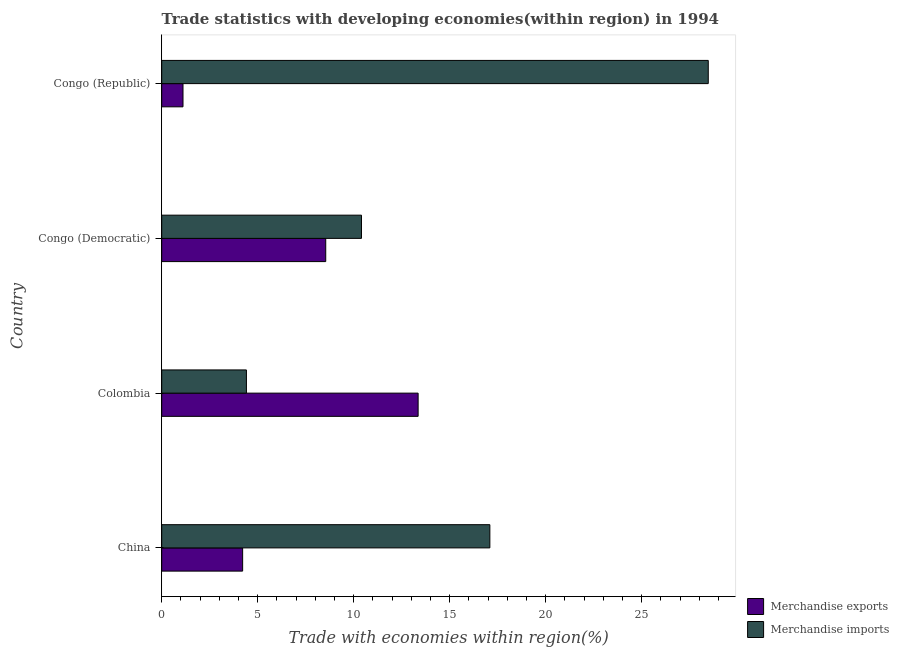How many bars are there on the 3rd tick from the top?
Make the answer very short. 2. What is the label of the 2nd group of bars from the top?
Offer a terse response. Congo (Democratic). In how many cases, is the number of bars for a given country not equal to the number of legend labels?
Make the answer very short. 0. What is the merchandise imports in China?
Make the answer very short. 17.09. Across all countries, what is the maximum merchandise imports?
Give a very brief answer. 28.47. Across all countries, what is the minimum merchandise imports?
Give a very brief answer. 4.41. In which country was the merchandise imports maximum?
Offer a very short reply. Congo (Republic). What is the total merchandise exports in the graph?
Provide a short and direct response. 27.22. What is the difference between the merchandise imports in China and that in Colombia?
Provide a succinct answer. 12.68. What is the difference between the merchandise imports in China and the merchandise exports in Congo (Republic)?
Your response must be concise. 15.98. What is the average merchandise exports per country?
Offer a terse response. 6.81. What is the difference between the merchandise imports and merchandise exports in Congo (Democratic)?
Provide a succinct answer. 1.86. In how many countries, is the merchandise exports greater than 9 %?
Provide a succinct answer. 1. What is the ratio of the merchandise exports in Colombia to that in Congo (Democratic)?
Give a very brief answer. 1.56. Is the difference between the merchandise imports in Colombia and Congo (Republic) greater than the difference between the merchandise exports in Colombia and Congo (Republic)?
Ensure brevity in your answer.  No. What is the difference between the highest and the second highest merchandise exports?
Provide a short and direct response. 4.81. What is the difference between the highest and the lowest merchandise imports?
Provide a succinct answer. 24.06. In how many countries, is the merchandise exports greater than the average merchandise exports taken over all countries?
Give a very brief answer. 2. What does the 1st bar from the top in China represents?
Give a very brief answer. Merchandise imports. Are all the bars in the graph horizontal?
Provide a succinct answer. Yes. How many countries are there in the graph?
Your response must be concise. 4. What is the difference between two consecutive major ticks on the X-axis?
Provide a succinct answer. 5. Does the graph contain any zero values?
Keep it short and to the point. No. Does the graph contain grids?
Provide a short and direct response. No. Where does the legend appear in the graph?
Ensure brevity in your answer.  Bottom right. How many legend labels are there?
Your answer should be compact. 2. What is the title of the graph?
Your response must be concise. Trade statistics with developing economies(within region) in 1994. Does "Investment" appear as one of the legend labels in the graph?
Give a very brief answer. No. What is the label or title of the X-axis?
Keep it short and to the point. Trade with economies within region(%). What is the label or title of the Y-axis?
Give a very brief answer. Country. What is the Trade with economies within region(%) in Merchandise exports in China?
Ensure brevity in your answer.  4.22. What is the Trade with economies within region(%) of Merchandise imports in China?
Your answer should be compact. 17.09. What is the Trade with economies within region(%) in Merchandise exports in Colombia?
Offer a terse response. 13.36. What is the Trade with economies within region(%) of Merchandise imports in Colombia?
Provide a short and direct response. 4.41. What is the Trade with economies within region(%) in Merchandise exports in Congo (Democratic)?
Your answer should be compact. 8.54. What is the Trade with economies within region(%) in Merchandise imports in Congo (Democratic)?
Offer a very short reply. 10.41. What is the Trade with economies within region(%) in Merchandise exports in Congo (Republic)?
Provide a succinct answer. 1.11. What is the Trade with economies within region(%) in Merchandise imports in Congo (Republic)?
Make the answer very short. 28.47. Across all countries, what is the maximum Trade with economies within region(%) in Merchandise exports?
Your answer should be compact. 13.36. Across all countries, what is the maximum Trade with economies within region(%) in Merchandise imports?
Offer a terse response. 28.47. Across all countries, what is the minimum Trade with economies within region(%) in Merchandise exports?
Give a very brief answer. 1.11. Across all countries, what is the minimum Trade with economies within region(%) of Merchandise imports?
Offer a terse response. 4.41. What is the total Trade with economies within region(%) of Merchandise exports in the graph?
Your answer should be very brief. 27.22. What is the total Trade with economies within region(%) of Merchandise imports in the graph?
Your answer should be very brief. 60.38. What is the difference between the Trade with economies within region(%) of Merchandise exports in China and that in Colombia?
Provide a short and direct response. -9.14. What is the difference between the Trade with economies within region(%) in Merchandise imports in China and that in Colombia?
Your response must be concise. 12.68. What is the difference between the Trade with economies within region(%) of Merchandise exports in China and that in Congo (Democratic)?
Make the answer very short. -4.33. What is the difference between the Trade with economies within region(%) in Merchandise imports in China and that in Congo (Democratic)?
Provide a short and direct response. 6.69. What is the difference between the Trade with economies within region(%) in Merchandise exports in China and that in Congo (Republic)?
Provide a short and direct response. 3.11. What is the difference between the Trade with economies within region(%) of Merchandise imports in China and that in Congo (Republic)?
Your response must be concise. -11.38. What is the difference between the Trade with economies within region(%) of Merchandise exports in Colombia and that in Congo (Democratic)?
Provide a succinct answer. 4.81. What is the difference between the Trade with economies within region(%) of Merchandise imports in Colombia and that in Congo (Democratic)?
Your response must be concise. -5.99. What is the difference between the Trade with economies within region(%) of Merchandise exports in Colombia and that in Congo (Republic)?
Make the answer very short. 12.25. What is the difference between the Trade with economies within region(%) in Merchandise imports in Colombia and that in Congo (Republic)?
Keep it short and to the point. -24.06. What is the difference between the Trade with economies within region(%) of Merchandise exports in Congo (Democratic) and that in Congo (Republic)?
Give a very brief answer. 7.43. What is the difference between the Trade with economies within region(%) in Merchandise imports in Congo (Democratic) and that in Congo (Republic)?
Offer a very short reply. -18.06. What is the difference between the Trade with economies within region(%) in Merchandise exports in China and the Trade with economies within region(%) in Merchandise imports in Colombia?
Your answer should be very brief. -0.2. What is the difference between the Trade with economies within region(%) in Merchandise exports in China and the Trade with economies within region(%) in Merchandise imports in Congo (Democratic)?
Offer a very short reply. -6.19. What is the difference between the Trade with economies within region(%) of Merchandise exports in China and the Trade with economies within region(%) of Merchandise imports in Congo (Republic)?
Give a very brief answer. -24.25. What is the difference between the Trade with economies within region(%) in Merchandise exports in Colombia and the Trade with economies within region(%) in Merchandise imports in Congo (Democratic)?
Make the answer very short. 2.95. What is the difference between the Trade with economies within region(%) of Merchandise exports in Colombia and the Trade with economies within region(%) of Merchandise imports in Congo (Republic)?
Provide a succinct answer. -15.11. What is the difference between the Trade with economies within region(%) in Merchandise exports in Congo (Democratic) and the Trade with economies within region(%) in Merchandise imports in Congo (Republic)?
Your answer should be compact. -19.92. What is the average Trade with economies within region(%) of Merchandise exports per country?
Give a very brief answer. 6.81. What is the average Trade with economies within region(%) of Merchandise imports per country?
Your answer should be very brief. 15.09. What is the difference between the Trade with economies within region(%) of Merchandise exports and Trade with economies within region(%) of Merchandise imports in China?
Keep it short and to the point. -12.88. What is the difference between the Trade with economies within region(%) of Merchandise exports and Trade with economies within region(%) of Merchandise imports in Colombia?
Make the answer very short. 8.94. What is the difference between the Trade with economies within region(%) in Merchandise exports and Trade with economies within region(%) in Merchandise imports in Congo (Democratic)?
Ensure brevity in your answer.  -1.86. What is the difference between the Trade with economies within region(%) of Merchandise exports and Trade with economies within region(%) of Merchandise imports in Congo (Republic)?
Keep it short and to the point. -27.36. What is the ratio of the Trade with economies within region(%) in Merchandise exports in China to that in Colombia?
Provide a succinct answer. 0.32. What is the ratio of the Trade with economies within region(%) of Merchandise imports in China to that in Colombia?
Provide a succinct answer. 3.87. What is the ratio of the Trade with economies within region(%) in Merchandise exports in China to that in Congo (Democratic)?
Offer a terse response. 0.49. What is the ratio of the Trade with economies within region(%) in Merchandise imports in China to that in Congo (Democratic)?
Your response must be concise. 1.64. What is the ratio of the Trade with economies within region(%) of Merchandise exports in China to that in Congo (Republic)?
Your answer should be compact. 3.8. What is the ratio of the Trade with economies within region(%) in Merchandise imports in China to that in Congo (Republic)?
Make the answer very short. 0.6. What is the ratio of the Trade with economies within region(%) in Merchandise exports in Colombia to that in Congo (Democratic)?
Your answer should be very brief. 1.56. What is the ratio of the Trade with economies within region(%) in Merchandise imports in Colombia to that in Congo (Democratic)?
Provide a succinct answer. 0.42. What is the ratio of the Trade with economies within region(%) in Merchandise exports in Colombia to that in Congo (Republic)?
Offer a terse response. 12.04. What is the ratio of the Trade with economies within region(%) in Merchandise imports in Colombia to that in Congo (Republic)?
Your answer should be very brief. 0.15. What is the ratio of the Trade with economies within region(%) of Merchandise exports in Congo (Democratic) to that in Congo (Republic)?
Make the answer very short. 7.7. What is the ratio of the Trade with economies within region(%) in Merchandise imports in Congo (Democratic) to that in Congo (Republic)?
Your answer should be compact. 0.37. What is the difference between the highest and the second highest Trade with economies within region(%) in Merchandise exports?
Keep it short and to the point. 4.81. What is the difference between the highest and the second highest Trade with economies within region(%) of Merchandise imports?
Offer a very short reply. 11.38. What is the difference between the highest and the lowest Trade with economies within region(%) of Merchandise exports?
Offer a terse response. 12.25. What is the difference between the highest and the lowest Trade with economies within region(%) in Merchandise imports?
Offer a very short reply. 24.06. 